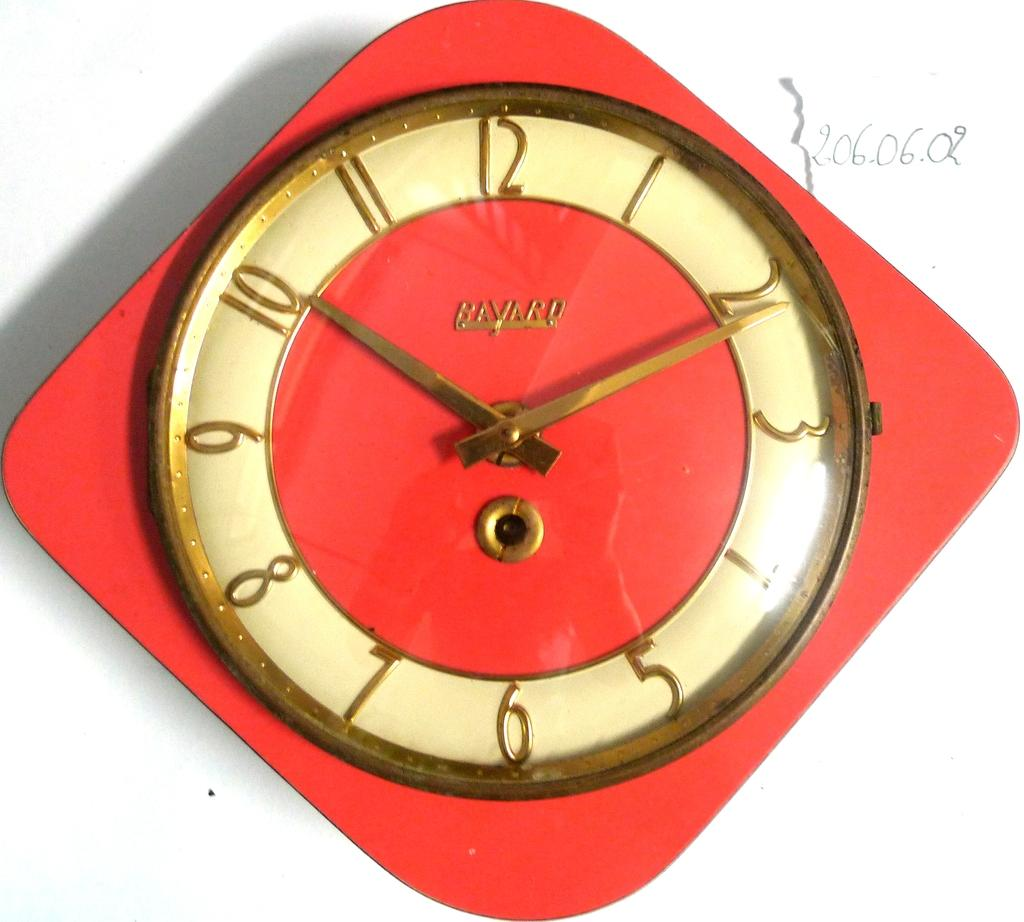<image>
Offer a succinct explanation of the picture presented. A Bayard clock showing the time to be 10:11 in gold numbers. 